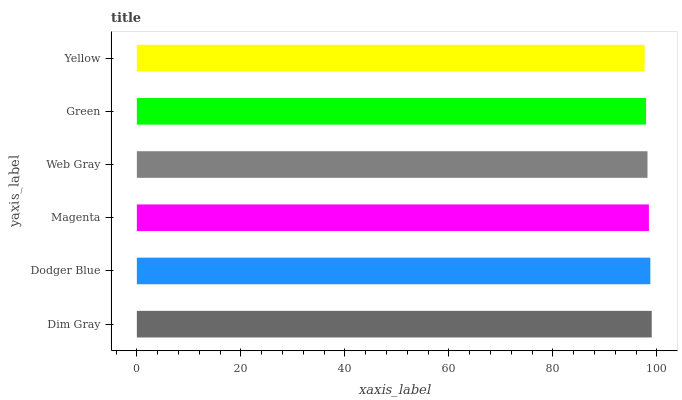Is Yellow the minimum?
Answer yes or no. Yes. Is Dim Gray the maximum?
Answer yes or no. Yes. Is Dodger Blue the minimum?
Answer yes or no. No. Is Dodger Blue the maximum?
Answer yes or no. No. Is Dim Gray greater than Dodger Blue?
Answer yes or no. Yes. Is Dodger Blue less than Dim Gray?
Answer yes or no. Yes. Is Dodger Blue greater than Dim Gray?
Answer yes or no. No. Is Dim Gray less than Dodger Blue?
Answer yes or no. No. Is Magenta the high median?
Answer yes or no. Yes. Is Web Gray the low median?
Answer yes or no. Yes. Is Dodger Blue the high median?
Answer yes or no. No. Is Dodger Blue the low median?
Answer yes or no. No. 